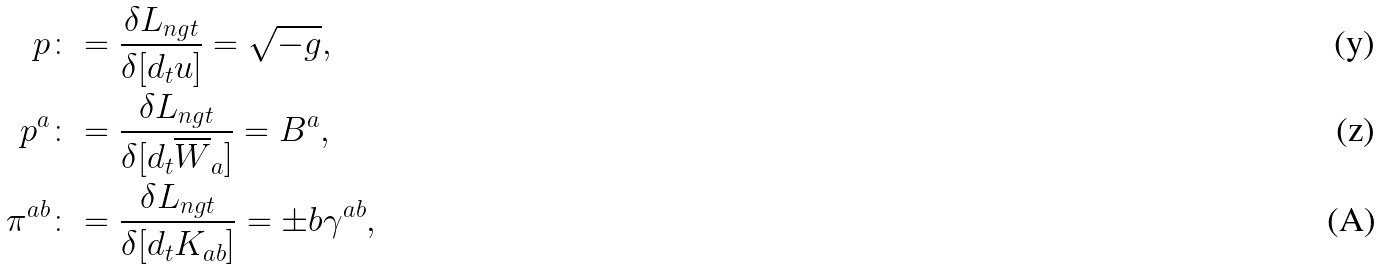<formula> <loc_0><loc_0><loc_500><loc_500>p & \colon = \frac { \delta { L _ { n g t } } } { \delta [ d _ { t } u ] } = \sqrt { - g } , \\ p ^ { a } & \colon = \frac { \delta { L _ { n g t } } } { \delta [ d _ { t } \overline { W } _ { a } ] } = B ^ { a } , \\ \pi ^ { a b } & \colon = \frac { \delta { L _ { n g t } } } { \delta [ d _ { t } { K } _ { a b } ] } = \pm b { \gamma } ^ { a b } ,</formula> 